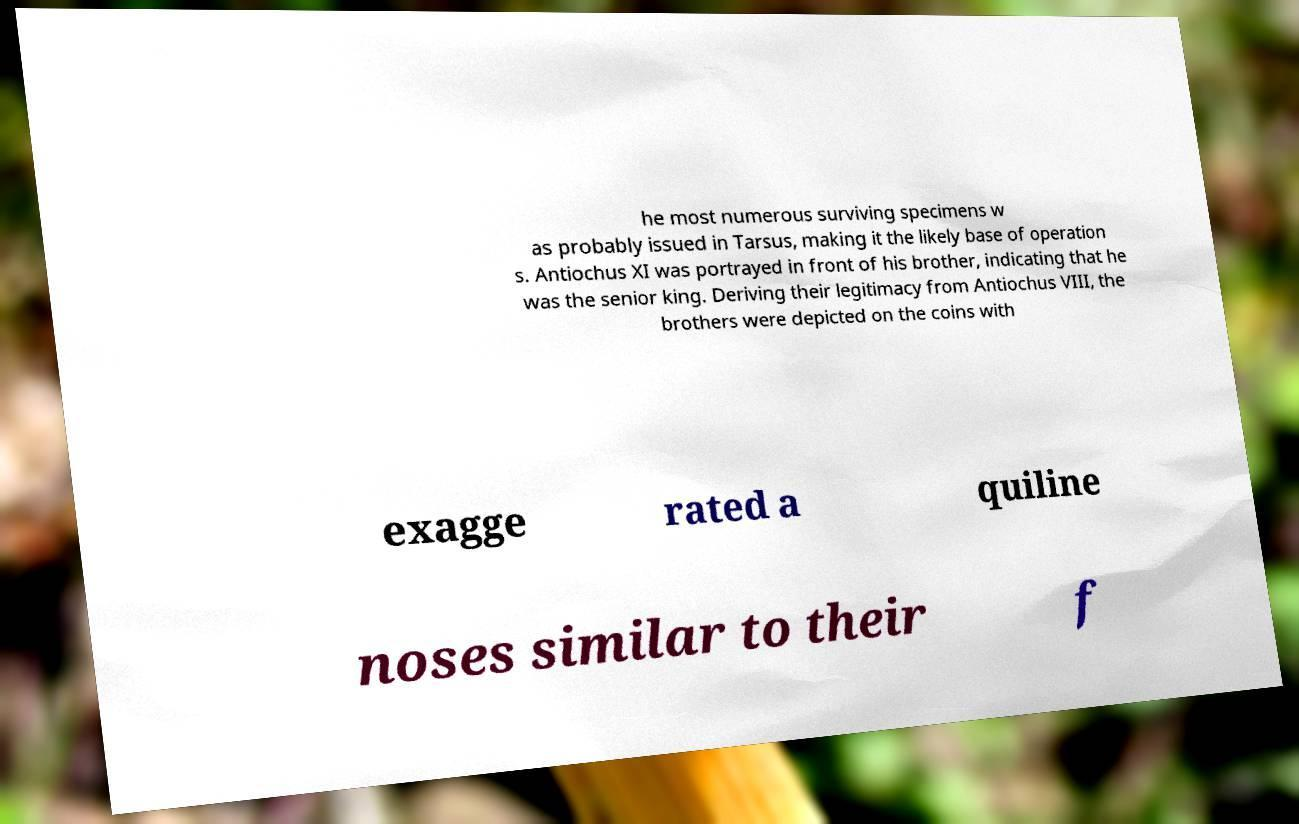I need the written content from this picture converted into text. Can you do that? he most numerous surviving specimens w as probably issued in Tarsus, making it the likely base of operation s. Antiochus XI was portrayed in front of his brother, indicating that he was the senior king. Deriving their legitimacy from Antiochus VIII, the brothers were depicted on the coins with exagge rated a quiline noses similar to their f 